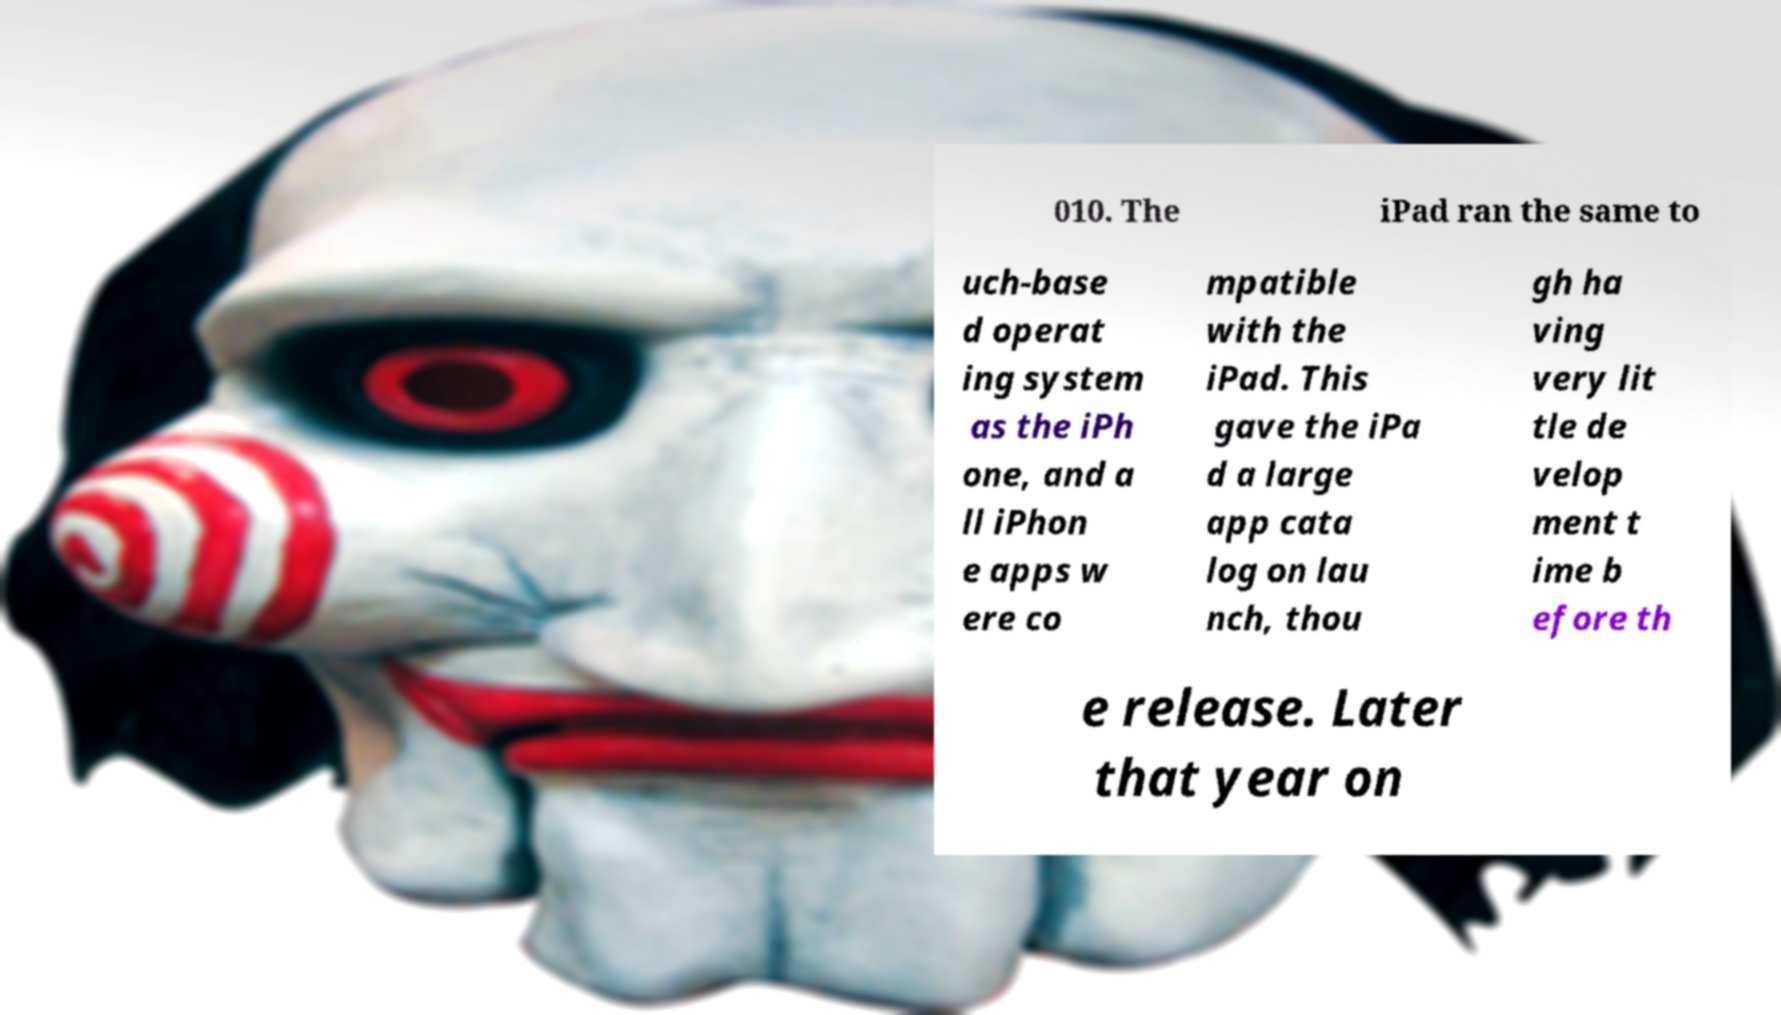I need the written content from this picture converted into text. Can you do that? 010. The iPad ran the same to uch-base d operat ing system as the iPh one, and a ll iPhon e apps w ere co mpatible with the iPad. This gave the iPa d a large app cata log on lau nch, thou gh ha ving very lit tle de velop ment t ime b efore th e release. Later that year on 